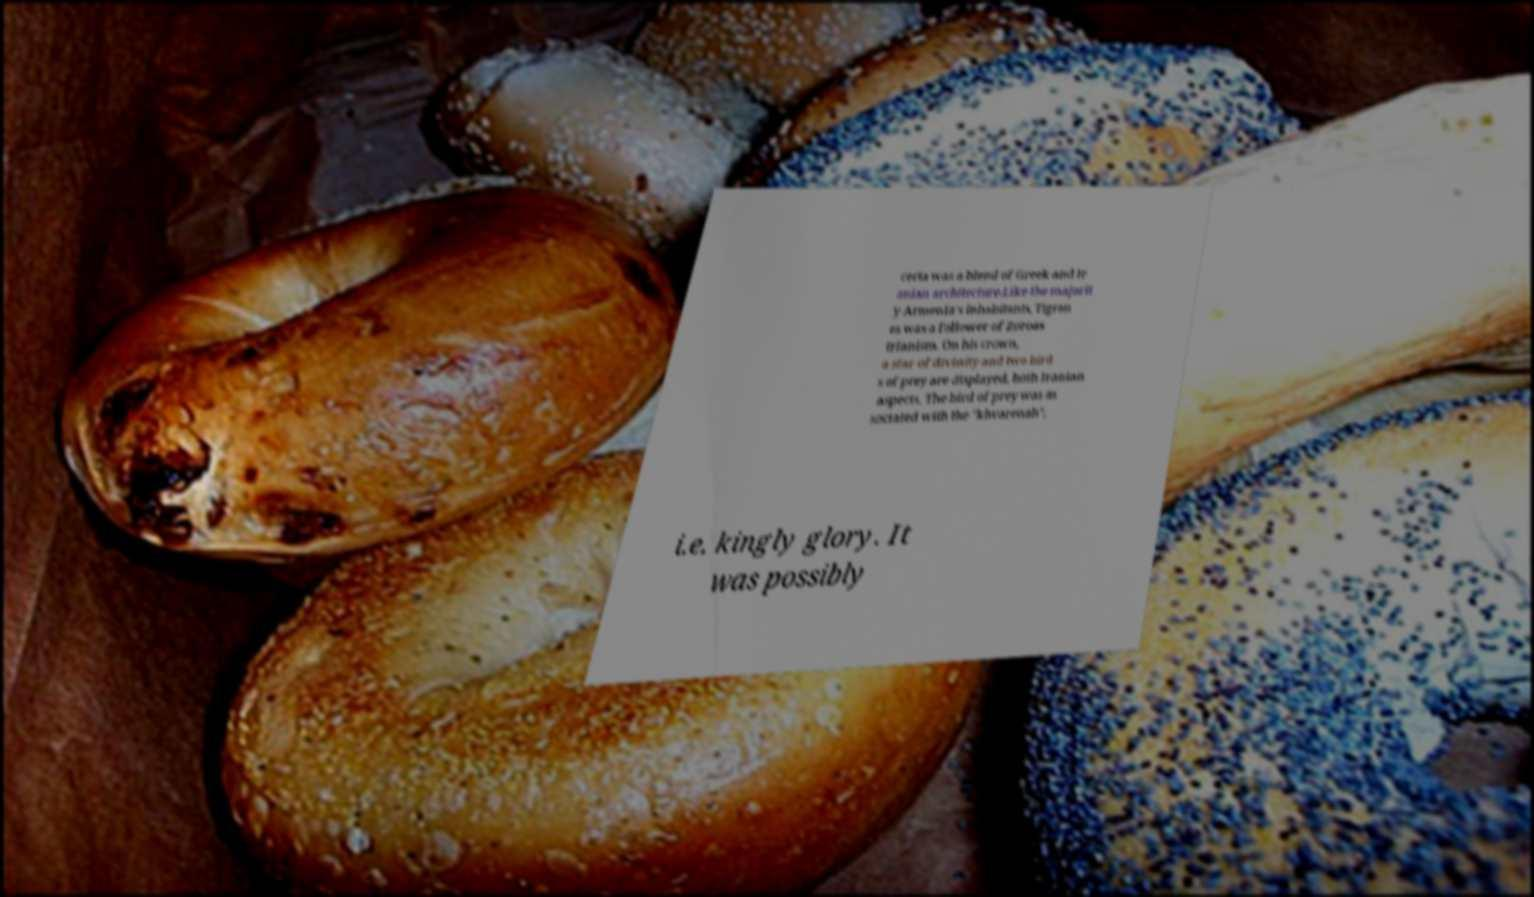Please read and relay the text visible in this image. What does it say? certa was a blend of Greek and Ir anian architecture.Like the majorit y Armenia's inhabitants, Tigran es was a follower of Zoroas trianism. On his crown, a star of divinity and two bird s of prey are displayed, both Iranian aspects. The bird of prey was as sociated with the "khvarenah", i.e. kingly glory. It was possibly 